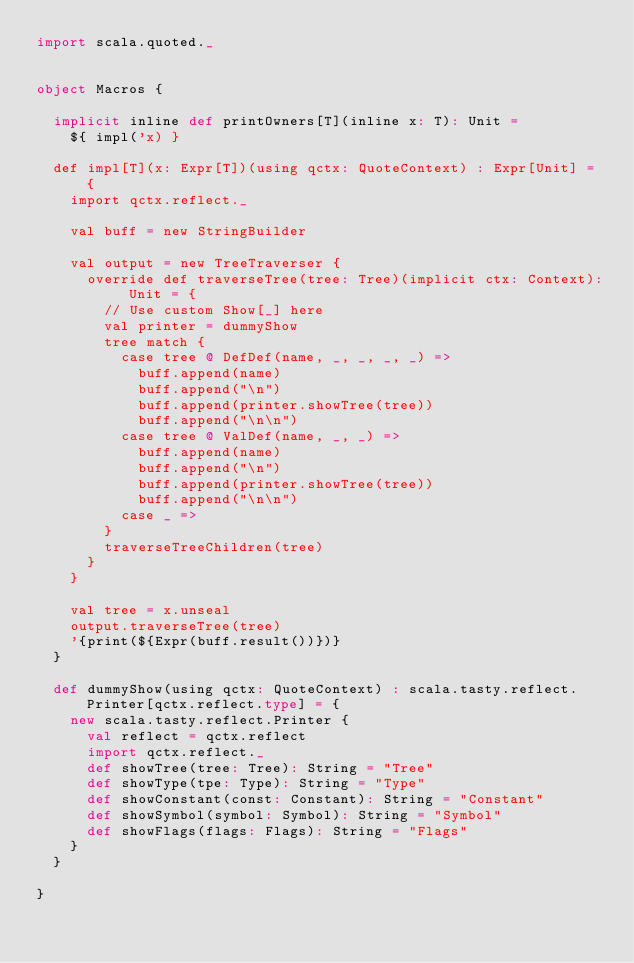<code> <loc_0><loc_0><loc_500><loc_500><_Scala_>import scala.quoted._


object Macros {

  implicit inline def printOwners[T](inline x: T): Unit =
    ${ impl('x) }

  def impl[T](x: Expr[T])(using qctx: QuoteContext) : Expr[Unit] = {
    import qctx.reflect._

    val buff = new StringBuilder

    val output = new TreeTraverser {
      override def traverseTree(tree: Tree)(implicit ctx: Context): Unit = {
        // Use custom Show[_] here
        val printer = dummyShow
        tree match {
          case tree @ DefDef(name, _, _, _, _) =>
            buff.append(name)
            buff.append("\n")
            buff.append(printer.showTree(tree))
            buff.append("\n\n")
          case tree @ ValDef(name, _, _) =>
            buff.append(name)
            buff.append("\n")
            buff.append(printer.showTree(tree))
            buff.append("\n\n")
          case _ =>
        }
        traverseTreeChildren(tree)
      }
    }

    val tree = x.unseal
    output.traverseTree(tree)
    '{print(${Expr(buff.result())})}
  }

  def dummyShow(using qctx: QuoteContext) : scala.tasty.reflect.Printer[qctx.reflect.type] = {
    new scala.tasty.reflect.Printer {
      val reflect = qctx.reflect
      import qctx.reflect._
      def showTree(tree: Tree): String = "Tree"
      def showType(tpe: Type): String = "Type"
      def showConstant(const: Constant): String = "Constant"
      def showSymbol(symbol: Symbol): String = "Symbol"
      def showFlags(flags: Flags): String = "Flags"
    }
  }

}
</code> 